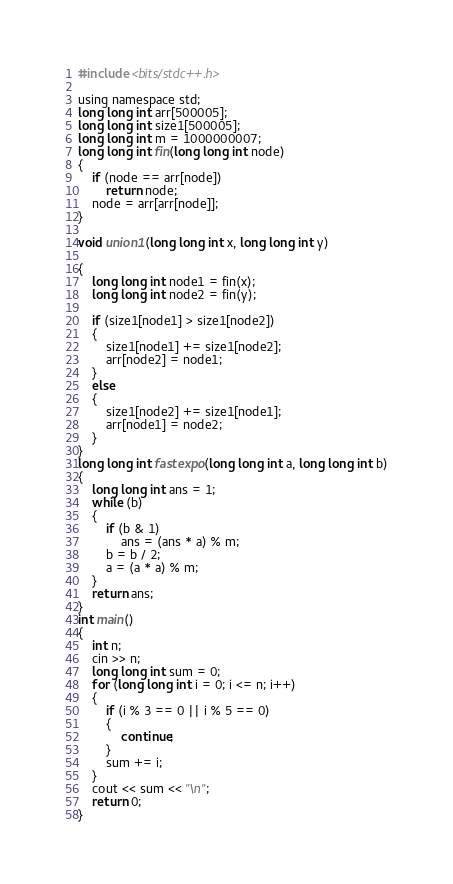Convert code to text. <code><loc_0><loc_0><loc_500><loc_500><_C_>#include <bits/stdc++.h>

using namespace std;
long long int arr[500005];
long long int size1[500005];
long long int m = 1000000007;
long long int fin(long long int node)
{
    if (node == arr[node])
        return node;
    node = arr[arr[node]];
}

void union1(long long int x, long long int y)

{
    long long int node1 = fin(x);
    long long int node2 = fin(y);

    if (size1[node1] > size1[node2])
    {
        size1[node1] += size1[node2];
        arr[node2] = node1;
    }
    else
    {
        size1[node2] += size1[node1];
        arr[node1] = node2;
    }
}
long long int fastexpo(long long int a, long long int b)
{
    long long int ans = 1;
    while (b)
    {
        if (b & 1)
            ans = (ans * a) % m;
        b = b / 2;
        a = (a * a) % m;
    }
    return ans;
}
int main()
{
    int n;
    cin >> n;
    long long int sum = 0;
    for (long long int i = 0; i <= n; i++)
    {
        if (i % 3 == 0 || i % 5 == 0)
        {
            continue;
        }
        sum += i;
    }
    cout << sum << "\n";
    return 0;
}</code> 